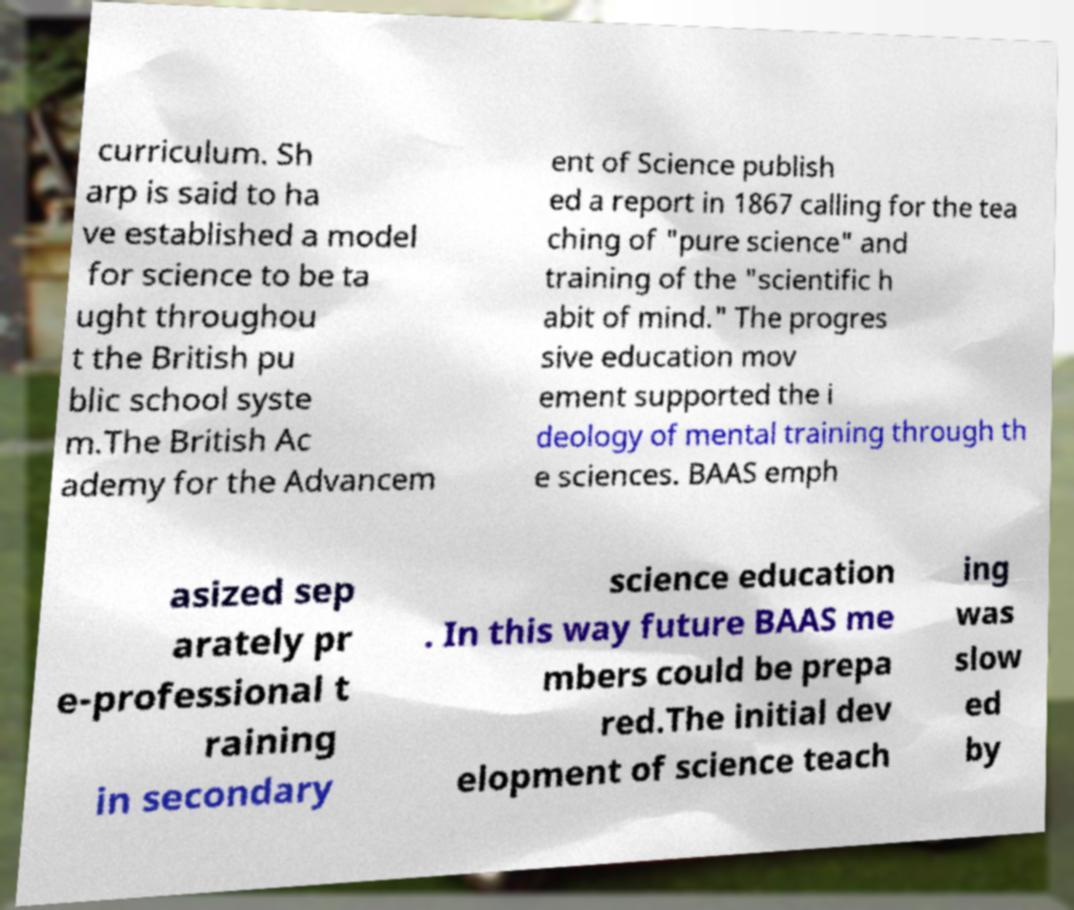I need the written content from this picture converted into text. Can you do that? curriculum. Sh arp is said to ha ve established a model for science to be ta ught throughou t the British pu blic school syste m.The British Ac ademy for the Advancem ent of Science publish ed a report in 1867 calling for the tea ching of "pure science" and training of the "scientific h abit of mind." The progres sive education mov ement supported the i deology of mental training through th e sciences. BAAS emph asized sep arately pr e-professional t raining in secondary science education . In this way future BAAS me mbers could be prepa red.The initial dev elopment of science teach ing was slow ed by 